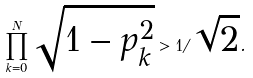Convert formula to latex. <formula><loc_0><loc_0><loc_500><loc_500>\prod _ { k = 0 } ^ { N } \sqrt { 1 - p _ { k } ^ { 2 } } > 1 / \sqrt { 2 } .</formula> 